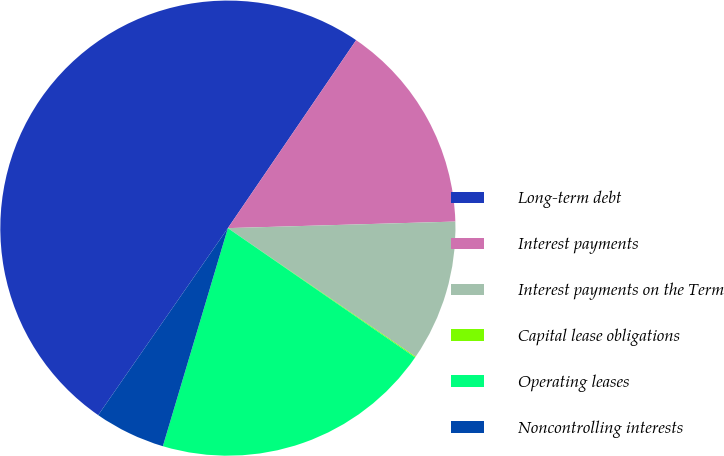Convert chart to OTSL. <chart><loc_0><loc_0><loc_500><loc_500><pie_chart><fcel>Long-term debt<fcel>Interest payments<fcel>Interest payments on the Term<fcel>Capital lease obligations<fcel>Operating leases<fcel>Noncontrolling interests<nl><fcel>49.88%<fcel>15.01%<fcel>10.02%<fcel>0.06%<fcel>19.99%<fcel>5.04%<nl></chart> 